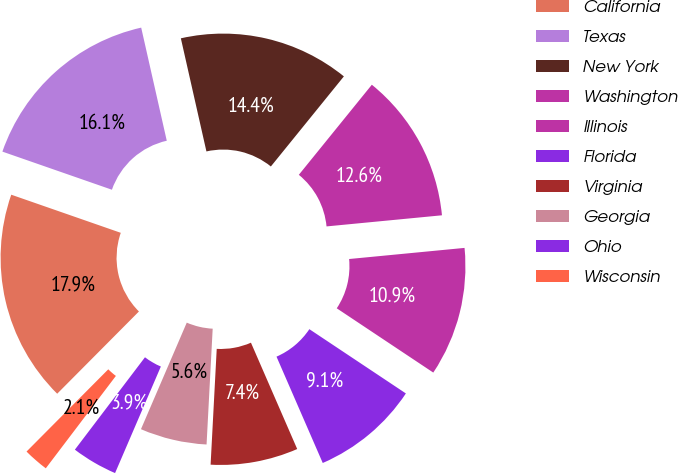Convert chart. <chart><loc_0><loc_0><loc_500><loc_500><pie_chart><fcel>California<fcel>Texas<fcel>New York<fcel>Washington<fcel>Illinois<fcel>Florida<fcel>Virginia<fcel>Georgia<fcel>Ohio<fcel>Wisconsin<nl><fcel>17.88%<fcel>16.13%<fcel>14.38%<fcel>12.63%<fcel>10.88%<fcel>9.12%<fcel>7.37%<fcel>5.62%<fcel>3.87%<fcel>2.12%<nl></chart> 